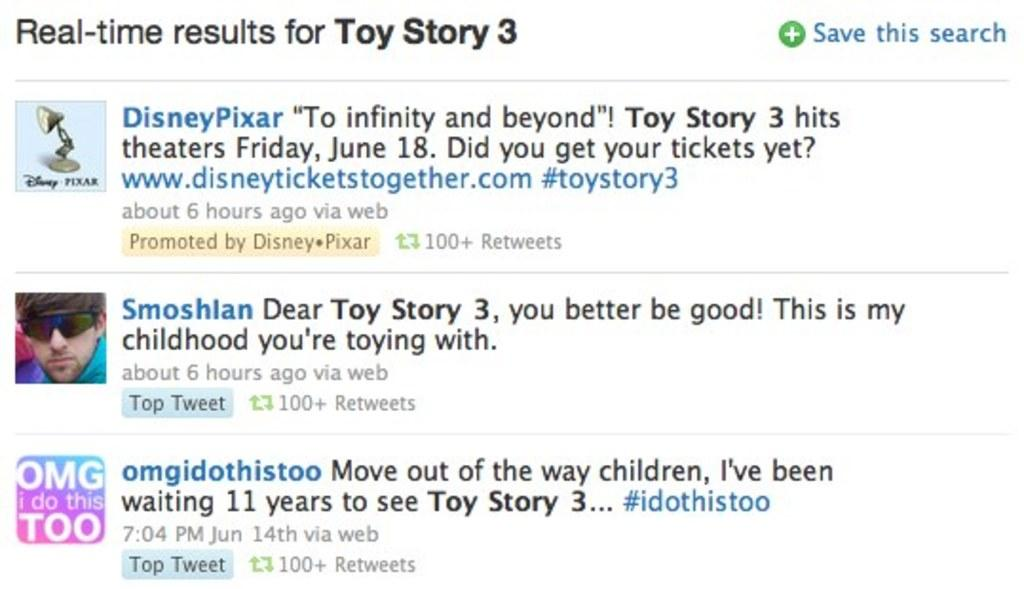What type of display is shown in the image? The image is a screen. What can be seen on the screen? There are texts and three images on the screen. What is the color of the background on the screen? The background of the screen is white in color. How many goldfish are swimming in the background of the screen? There are no goldfish present in the image, as it is a screen displaying texts and images with a white background. 